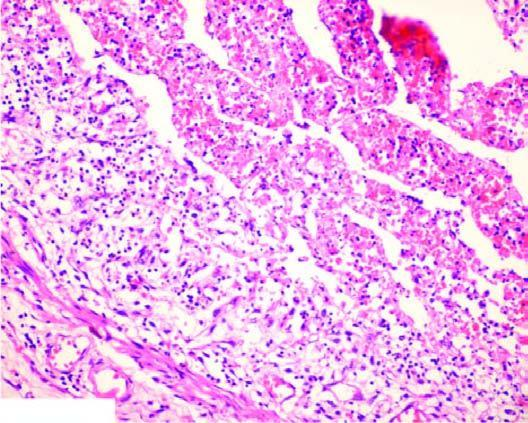s a scar smaller than the original wound acute panarteritis?
Answer the question using a single word or phrase. No 